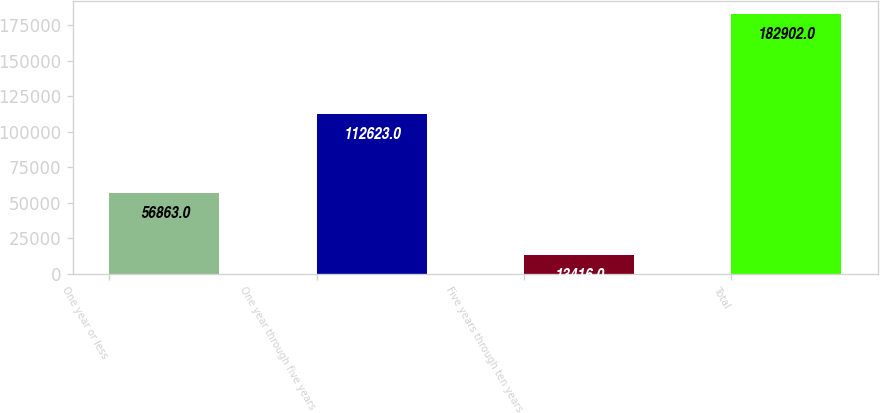<chart> <loc_0><loc_0><loc_500><loc_500><bar_chart><fcel>One year or less<fcel>One year through five years<fcel>Five years through ten years<fcel>Total<nl><fcel>56863<fcel>112623<fcel>13416<fcel>182902<nl></chart> 